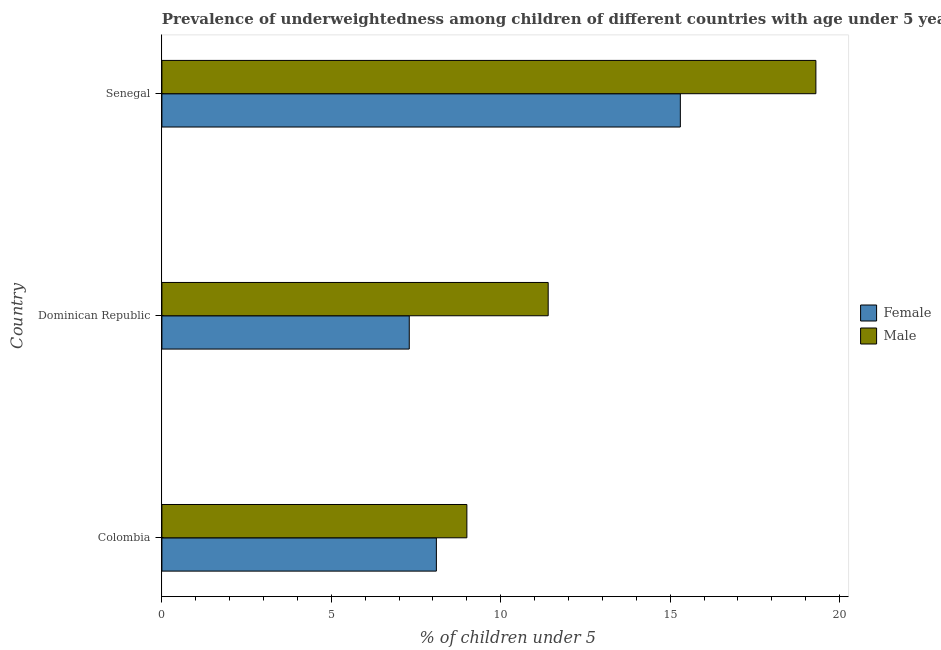Are the number of bars on each tick of the Y-axis equal?
Make the answer very short. Yes. What is the label of the 1st group of bars from the top?
Offer a terse response. Senegal. What is the percentage of underweighted male children in Senegal?
Give a very brief answer. 19.3. Across all countries, what is the maximum percentage of underweighted female children?
Your answer should be very brief. 15.3. Across all countries, what is the minimum percentage of underweighted female children?
Make the answer very short. 7.3. In which country was the percentage of underweighted male children maximum?
Make the answer very short. Senegal. In which country was the percentage of underweighted male children minimum?
Offer a terse response. Colombia. What is the total percentage of underweighted female children in the graph?
Ensure brevity in your answer.  30.7. What is the difference between the percentage of underweighted male children in Dominican Republic and the percentage of underweighted female children in Colombia?
Provide a succinct answer. 3.3. What is the average percentage of underweighted female children per country?
Provide a succinct answer. 10.23. What is the difference between the percentage of underweighted male children and percentage of underweighted female children in Colombia?
Ensure brevity in your answer.  0.9. In how many countries, is the percentage of underweighted female children greater than 19 %?
Your answer should be compact. 0. What is the ratio of the percentage of underweighted female children in Dominican Republic to that in Senegal?
Ensure brevity in your answer.  0.48. Is the difference between the percentage of underweighted male children in Colombia and Senegal greater than the difference between the percentage of underweighted female children in Colombia and Senegal?
Provide a short and direct response. No. What is the difference between the highest and the second highest percentage of underweighted male children?
Your answer should be compact. 7.9. What is the difference between the highest and the lowest percentage of underweighted female children?
Keep it short and to the point. 8. In how many countries, is the percentage of underweighted male children greater than the average percentage of underweighted male children taken over all countries?
Your answer should be compact. 1. What does the 1st bar from the top in Senegal represents?
Offer a very short reply. Male. Are the values on the major ticks of X-axis written in scientific E-notation?
Your answer should be very brief. No. Does the graph contain grids?
Your answer should be very brief. No. How many legend labels are there?
Make the answer very short. 2. What is the title of the graph?
Your answer should be compact. Prevalence of underweightedness among children of different countries with age under 5 years. Does "Primary school" appear as one of the legend labels in the graph?
Keep it short and to the point. No. What is the label or title of the X-axis?
Offer a terse response.  % of children under 5. What is the label or title of the Y-axis?
Make the answer very short. Country. What is the  % of children under 5 of Female in Colombia?
Offer a terse response. 8.1. What is the  % of children under 5 in Male in Colombia?
Your response must be concise. 9. What is the  % of children under 5 of Female in Dominican Republic?
Keep it short and to the point. 7.3. What is the  % of children under 5 of Male in Dominican Republic?
Give a very brief answer. 11.4. What is the  % of children under 5 of Female in Senegal?
Your response must be concise. 15.3. What is the  % of children under 5 in Male in Senegal?
Your response must be concise. 19.3. Across all countries, what is the maximum  % of children under 5 in Female?
Keep it short and to the point. 15.3. Across all countries, what is the maximum  % of children under 5 of Male?
Offer a very short reply. 19.3. Across all countries, what is the minimum  % of children under 5 in Female?
Keep it short and to the point. 7.3. Across all countries, what is the minimum  % of children under 5 of Male?
Provide a short and direct response. 9. What is the total  % of children under 5 of Female in the graph?
Your answer should be very brief. 30.7. What is the total  % of children under 5 in Male in the graph?
Your response must be concise. 39.7. What is the difference between the  % of children under 5 in Female in Colombia and that in Senegal?
Your answer should be very brief. -7.2. What is the difference between the  % of children under 5 of Male in Colombia and that in Senegal?
Keep it short and to the point. -10.3. What is the difference between the  % of children under 5 of Female in Dominican Republic and that in Senegal?
Ensure brevity in your answer.  -8. What is the difference between the  % of children under 5 in Male in Dominican Republic and that in Senegal?
Ensure brevity in your answer.  -7.9. What is the difference between the  % of children under 5 in Female in Colombia and the  % of children under 5 in Male in Senegal?
Keep it short and to the point. -11.2. What is the average  % of children under 5 in Female per country?
Your answer should be very brief. 10.23. What is the average  % of children under 5 of Male per country?
Ensure brevity in your answer.  13.23. What is the difference between the  % of children under 5 in Female and  % of children under 5 in Male in Senegal?
Provide a short and direct response. -4. What is the ratio of the  % of children under 5 of Female in Colombia to that in Dominican Republic?
Your answer should be compact. 1.11. What is the ratio of the  % of children under 5 in Male in Colombia to that in Dominican Republic?
Provide a succinct answer. 0.79. What is the ratio of the  % of children under 5 of Female in Colombia to that in Senegal?
Your answer should be compact. 0.53. What is the ratio of the  % of children under 5 of Male in Colombia to that in Senegal?
Offer a terse response. 0.47. What is the ratio of the  % of children under 5 of Female in Dominican Republic to that in Senegal?
Offer a very short reply. 0.48. What is the ratio of the  % of children under 5 in Male in Dominican Republic to that in Senegal?
Offer a terse response. 0.59. What is the difference between the highest and the second highest  % of children under 5 in Male?
Offer a terse response. 7.9. What is the difference between the highest and the lowest  % of children under 5 in Female?
Your response must be concise. 8. What is the difference between the highest and the lowest  % of children under 5 in Male?
Keep it short and to the point. 10.3. 